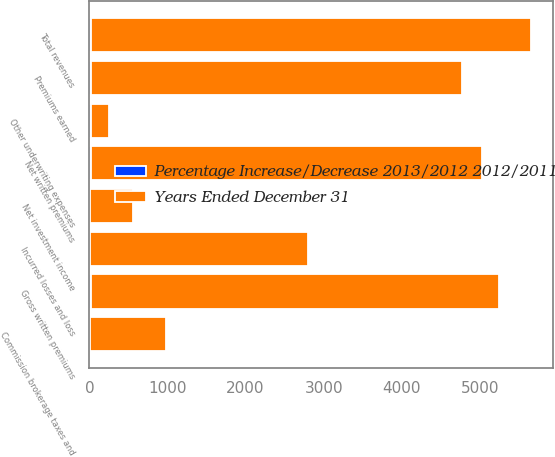<chart> <loc_0><loc_0><loc_500><loc_500><stacked_bar_chart><ecel><fcel>Gross written premiums<fcel>Net written premiums<fcel>Premiums earned<fcel>Net investment income<fcel>Total revenues<fcel>Incurred losses and loss<fcel>Commission brokerage taxes and<fcel>Other underwriting expenses<nl><fcel>Years Ended December 31<fcel>5218.6<fcel>5004.8<fcel>4753.5<fcel>548.5<fcel>5640.8<fcel>2800.3<fcel>977.6<fcel>237.1<nl><fcel>Percentage Increase/Decrease 2013/2012 2012/2011<fcel>21.1<fcel>22.6<fcel>14.1<fcel>8.6<fcel>14.6<fcel>2<fcel>2.6<fcel>14.2<nl></chart> 